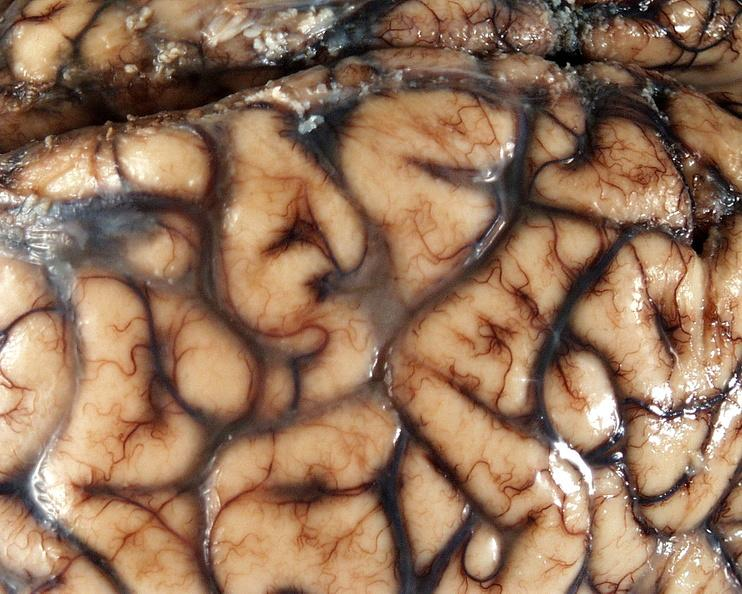does miliary tuberculosis show brain, cryptococcal meningitis?
Answer the question using a single word or phrase. No 